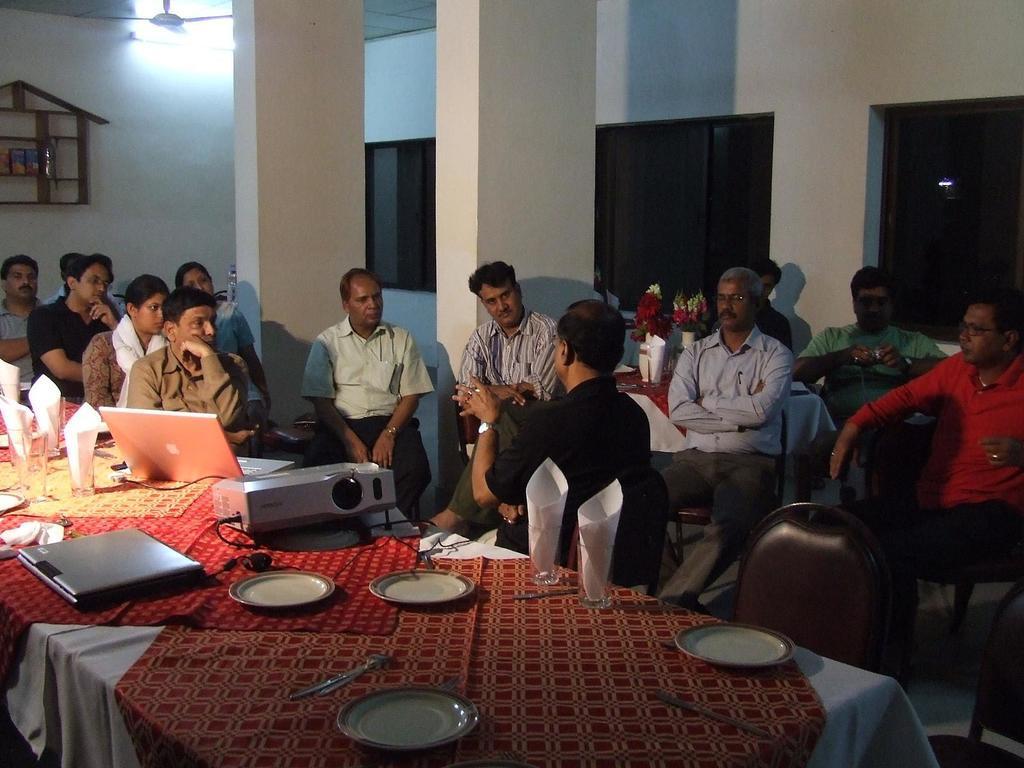Can you describe this image briefly? In this image In the middle there is a table on that there is a laptop, projector,plate, glass and tissues. On the right there is a man he wear red t shirt and trouser. In the middle there is a man he is sitting he wear shirt and trouser. In the background there is a wall, pillar and window. 